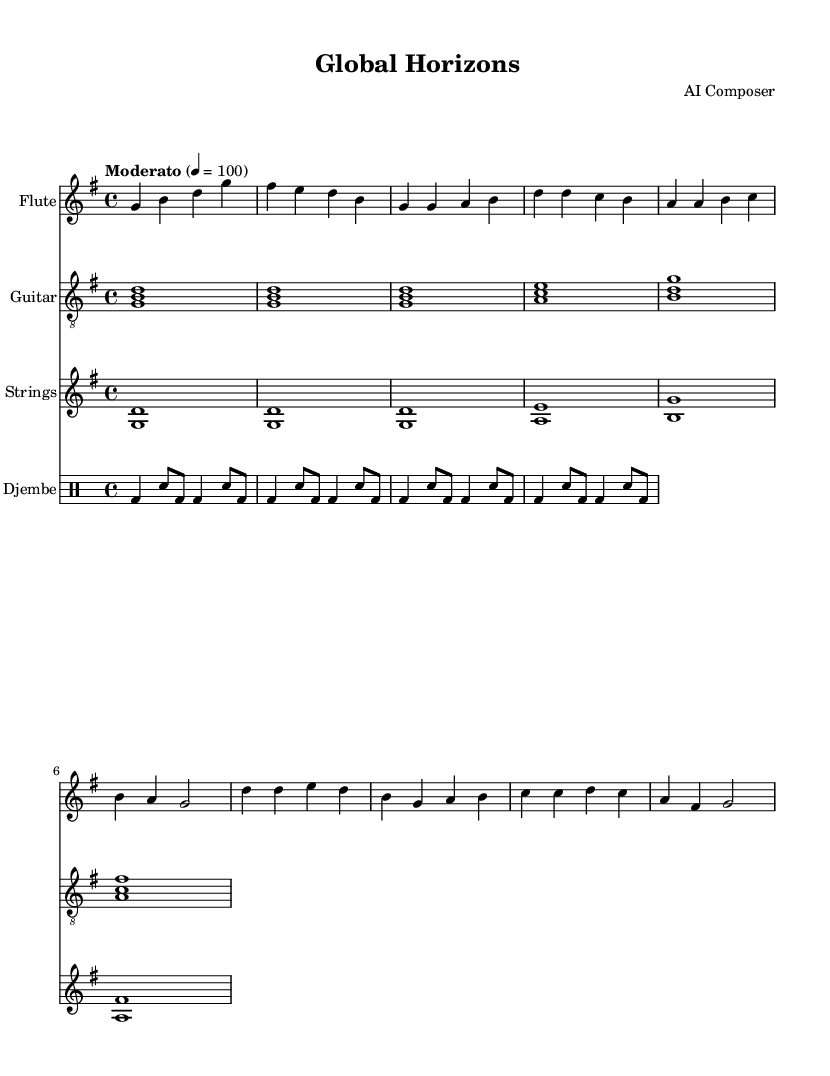What is the key signature of this music? The key signature shows one sharp (F#), indicating that it is in G major.
Answer: G major What is the time signature of this music? The top number (4) in the time signature indicates there are four beats in a measure, while the bottom number (4) signifies that a quarter note receives one beat.
Answer: 4/4 What tempo marking is indicated in the score? The tempo marking "Moderato" indicates a moderate speed, and the annotation "4 = 100" suggests each quarter note should be played at 100 beats per minute.
Answer: Moderato, 4 = 100 Which instrument has a simplified rhythm part? The djembe part, indicated with a distinctive drummode format, presents a simple rhythmic pattern, distinguishing it from melodic instruments.
Answer: Djembe How many measures does the flute part include in the intro? The flute intro consists of four measures based on the grouping of notes provided, confirming the number visually.
Answer: 4 measures What instrument's part uses chords instead of single notes? The guitar part is comprised of chord structures (e.g., <g b d>), showing harmonic content rather than just single melodic lines like other instruments.
Answer: Guitar What is the highest note played in the flute's part? The highest note in the flute section is d’ (D in the octave above middle C), which can be identified as it appears at the start of the chorus.
Answer: d’ 